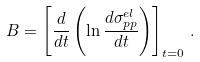<formula> <loc_0><loc_0><loc_500><loc_500>B = \left [ { \frac { d } { d t } } \left ( \ln { \frac { d \sigma _ { p p } ^ { e l } } { d t } } \right ) \right ] _ { t = 0 } \, .</formula> 